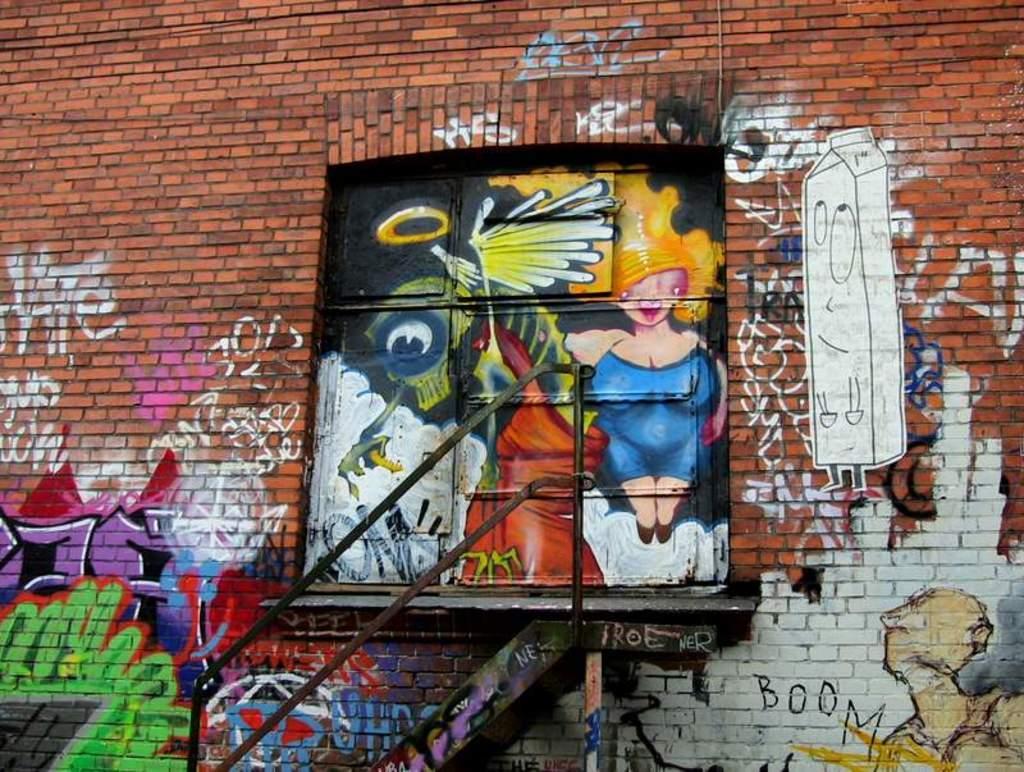Please provide a concise description of this image. In this picture we can see a brick wall, there is a painting on the wall. 